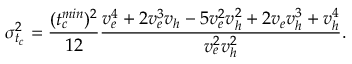<formula> <loc_0><loc_0><loc_500><loc_500>\sigma _ { t _ { c } } ^ { 2 } = \frac { ( t _ { c } ^ { \min } ) ^ { 2 } } { 1 2 } \frac { v _ { e } ^ { 4 } + 2 v _ { e } ^ { 3 } v _ { h } - 5 v _ { e } ^ { 2 } v _ { h } ^ { 2 } + 2 v _ { e } v _ { h } ^ { 3 } + v _ { h } ^ { 4 } } { v _ { e } ^ { 2 } v _ { h } ^ { 2 } } .</formula> 